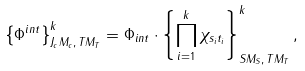<formula> <loc_0><loc_0><loc_500><loc_500>\left \{ \Phi ^ { i n t } \right \} ^ { k } _ { J _ { c } M _ { c } , \, T M _ { T } } = \Phi _ { i n t } \cdot \left \{ \prod _ { i = 1 } ^ { k } \chi _ { s _ { i } t _ { i } } \right \} ^ { k } _ { S M _ { S } , \, T M _ { T } } ,</formula> 